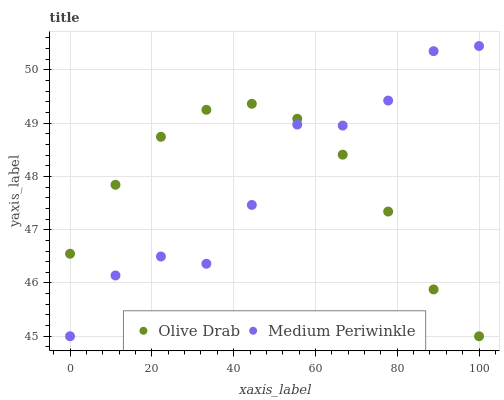Does Olive Drab have the minimum area under the curve?
Answer yes or no. Yes. Does Medium Periwinkle have the maximum area under the curve?
Answer yes or no. Yes. Does Olive Drab have the maximum area under the curve?
Answer yes or no. No. Is Olive Drab the smoothest?
Answer yes or no. Yes. Is Medium Periwinkle the roughest?
Answer yes or no. Yes. Is Olive Drab the roughest?
Answer yes or no. No. Does Medium Periwinkle have the lowest value?
Answer yes or no. Yes. Does Medium Periwinkle have the highest value?
Answer yes or no. Yes. Does Olive Drab have the highest value?
Answer yes or no. No. Does Olive Drab intersect Medium Periwinkle?
Answer yes or no. Yes. Is Olive Drab less than Medium Periwinkle?
Answer yes or no. No. Is Olive Drab greater than Medium Periwinkle?
Answer yes or no. No. 